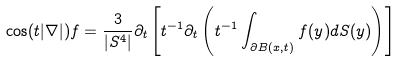<formula> <loc_0><loc_0><loc_500><loc_500>\cos ( t | \nabla | ) f & = \frac { 3 } { | S ^ { 4 } | } \partial _ { t } \left [ t ^ { - 1 } \partial _ { t } \left ( t ^ { - 1 } \int _ { \partial B ( x , t ) } f ( y ) d S ( y ) \right ) \right ]</formula> 